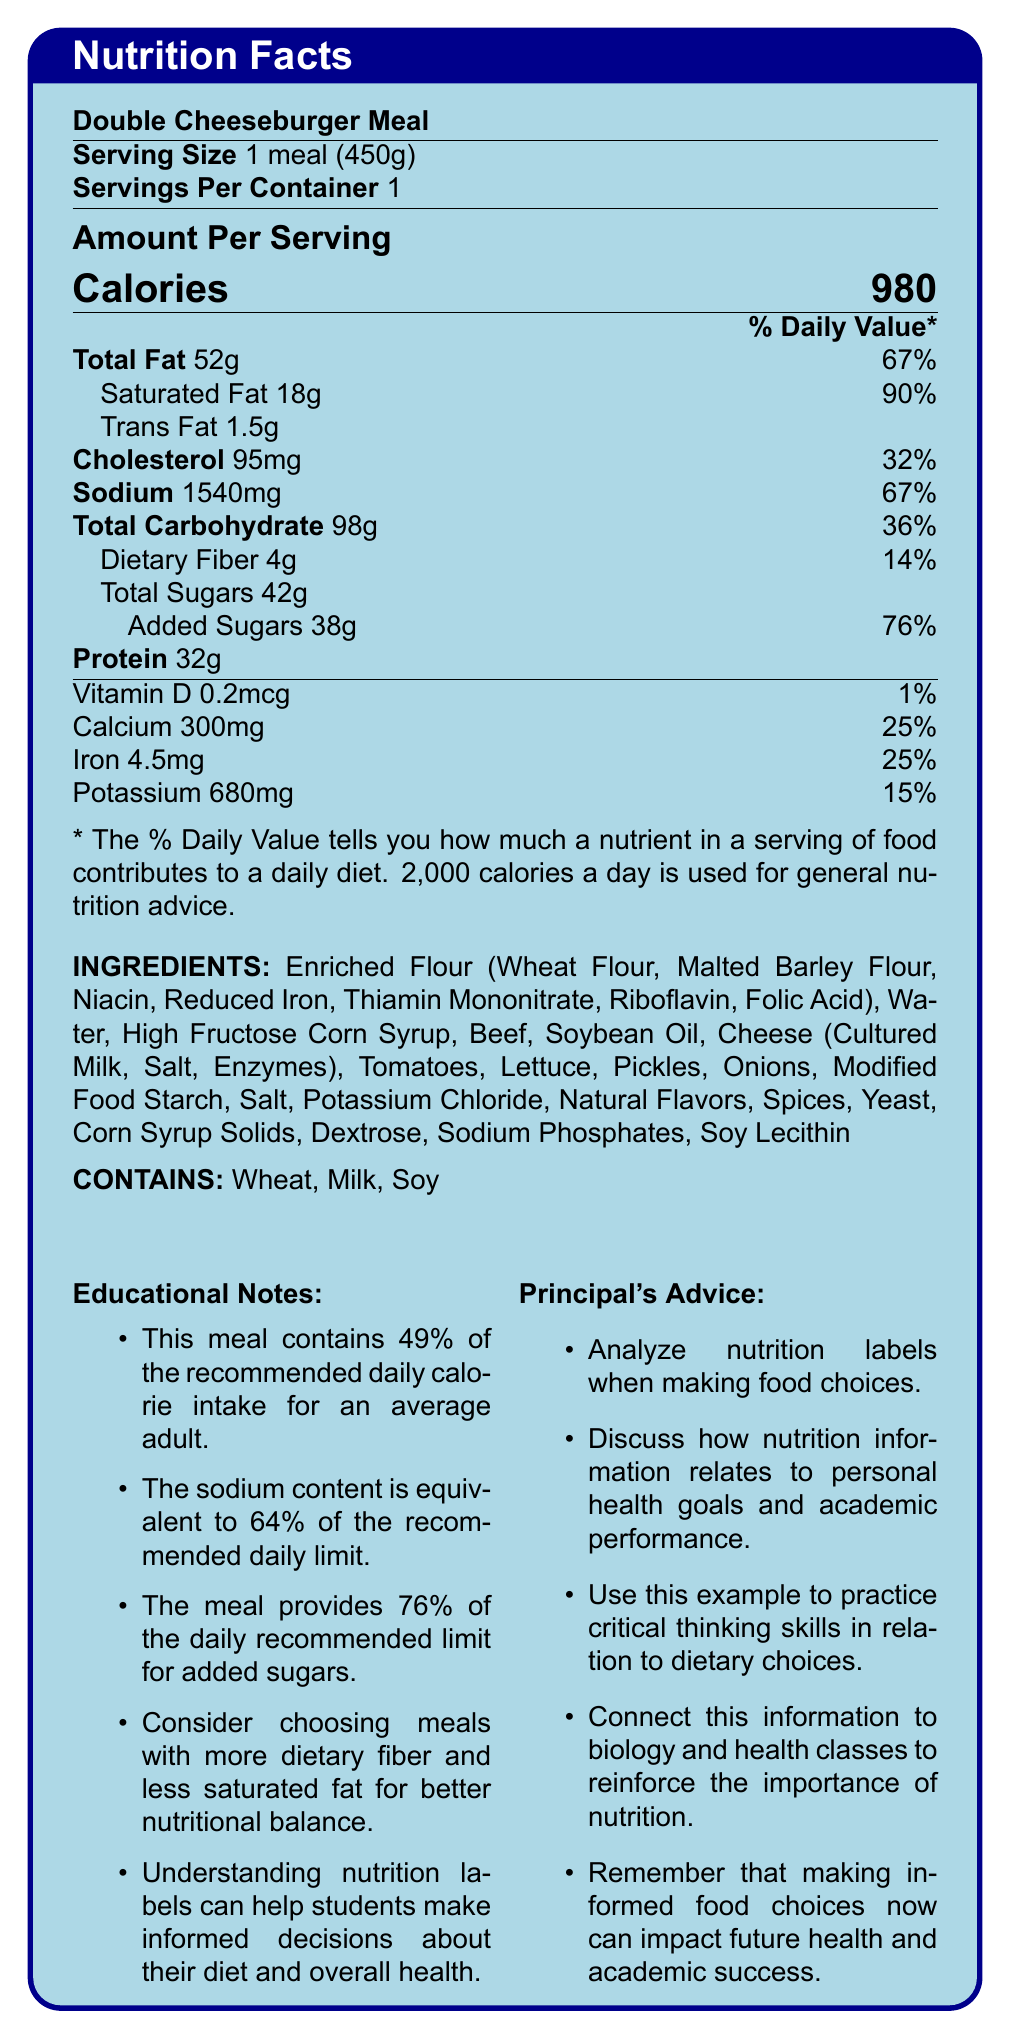what is the serving size of the Double Cheeseburger Meal? The serving size is specified as "1 meal (450g)" at the top of the nutrition facts table.
Answer: 1 meal (450g) how many calories are in one serving of the Double Cheeseburger Meal? The calories per serving are clearly listed as 980 under "Amount Per Serving".
Answer: 980 what is the percentage of the daily value of total fat in this meal? The percentage of the daily value for total fat is listed as 67%.
Answer: 67% how much sodium is in the Double Cheeseburger Meal? The sodium content is indicated as 1540mg.
Answer: 1540mg what are the main allergens listed in this meal? The allergens are stated as "Contains: Wheat, Milk, Soy".
Answer: Wheat, Milk, Soy which nutrient has the highest daily value percentage? A. Saturated Fat B. Sodium C. Added Sugars D. Total Carbohydrate Saturated Fat has the highest daily value percentage at 90%.
Answer: A how much protein is in the Double Cheeseburger Meal? The protein content is listed as 32g.
Answer: 32g what is the amount of cholesterol in this meal? The cholesterol amount is given as 95mg.
Answer: 95mg is the vitamin D content significant in this meal? The vitamin D content is only 0.2mcg, which is 1% of the daily value.
Answer: No does this meal contain more total carbohydrates or total fat? The meal contains 98g of total carbohydrates compared to 52g of total fat.
Answer: Total Carbohydrate which ingredient is not listed in the document? A. Enriched Flour B. Beef C. Chicken D. Tomatoes Chicken is not listed among the ingredients.
Answer: C how much of the daily recommended limit for added sugars does this meal provide? The meal provides 76% of the daily recommended limit for added sugars.
Answer: 76% what educational note suggests a balance in nutrition? This educational note advocates for a better nutritional balance by comparing dietary fiber and saturated fat.
Answer: Consider choosing meals with more dietary fiber and less saturated fat for better nutritional balance. is the sodium content in this meal nearly two-thirds of the recommended daily limit? The sodium content is 64% of the recommended daily limit, which is nearly two-thirds.
Answer: Yes what is the main purpose of the Principal's Advice section? The principal’s advice emphasizes analyzing nutrition labels, discussing nutritional information, practicing critical thinking, connecting it to health education, and considering long-term health impacts.
Answer: To encourage students to make informed dietary choices and understand the impact on health and academic performance. how many grams of sugars are added in the Double Cheeseburger Meal? The amount of added sugars is listed as 38g.
Answer: 38g describe the entire document in one sentence. The document includes comprehensive nutritional information, ingredients, allergens, educational notes, and a section with advice from a high school principal.
Answer: The document provides a detailed nutrition facts label for a Double Cheeseburger Meal, emphasizing the nutrient content, ingredients, allergens, educational notes, and advice from a principal on making informed dietary decisions. how much potassium is in this meal? The amount of potassium given is 680mg, but without the specific daily value limit for comparison, we cannot determine how it affects nutrient intake recommendations.
Answer: Not enough information 